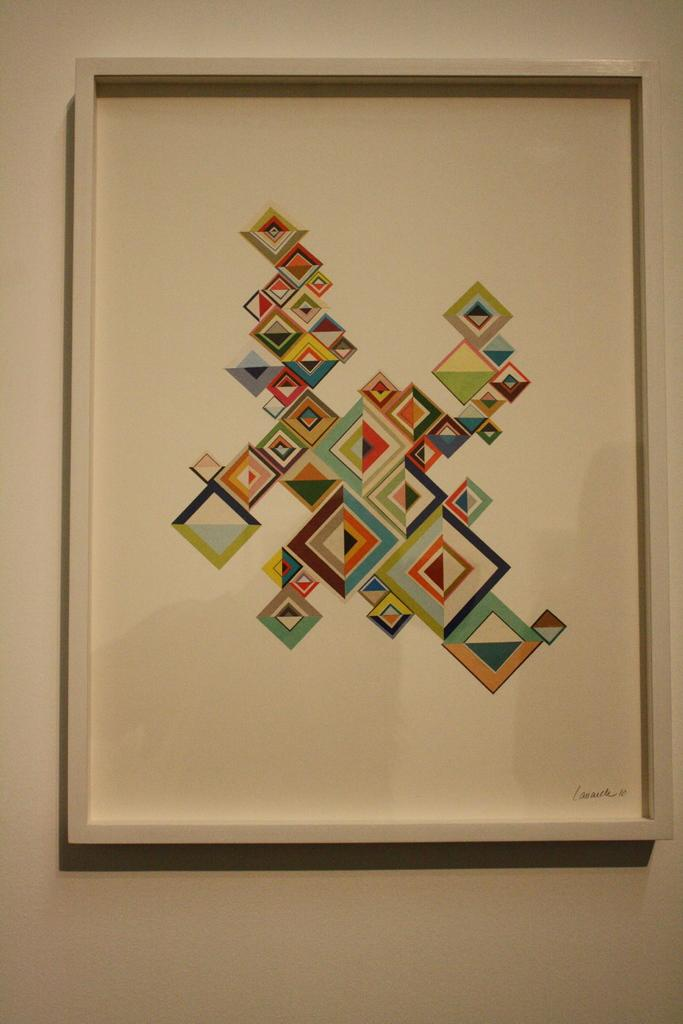What is present on the wall in the image? There is a photo on the wall in the image. Can you describe the wall in the image? The wall is a flat surface with a photo on it. What type of dinosaurs can be seen in the photo on the wall? There is no mention of dinosaurs in the image or the provided facts, so it cannot be determined if any dinosaurs are present in the photo. 